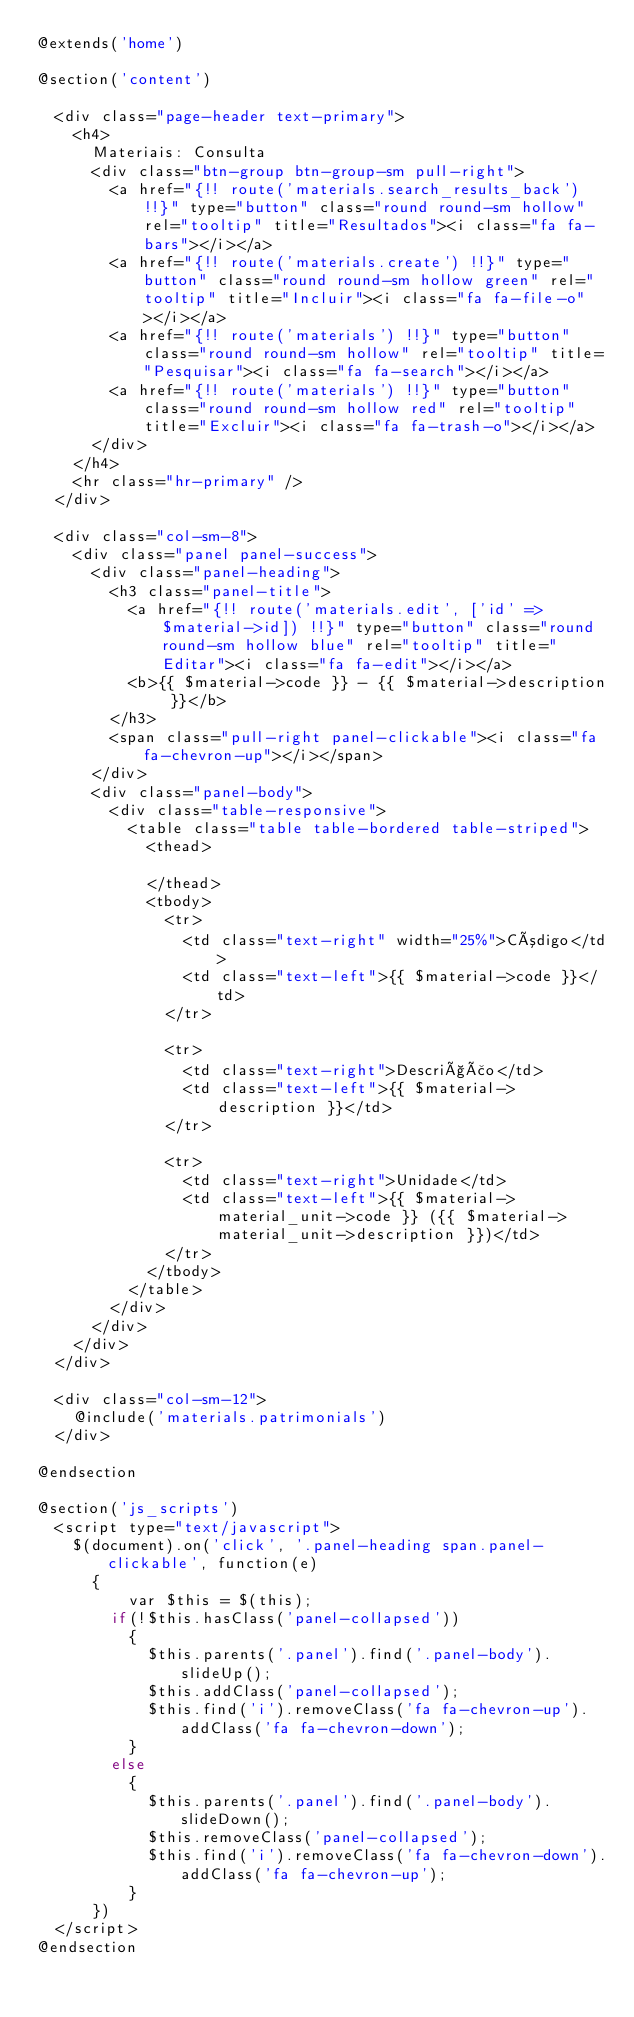<code> <loc_0><loc_0><loc_500><loc_500><_PHP_>@extends('home')

@section('content')

	<div class="page-header text-primary">
   	<h4>
     	Materiais: Consulta
     	<div class="btn-group btn-group-sm pull-right">
     		<a href="{!! route('materials.search_results_back') !!}" type="button" class="round round-sm hollow" rel="tooltip" title="Resultados"><i class="fa fa-bars"></i></a>
        <a href="{!! route('materials.create') !!}" type="button" class="round round-sm hollow green" rel="tooltip" title="Incluir"><i class="fa fa-file-o"></i></a>
     		<a href="{!! route('materials') !!}" type="button" class="round round-sm hollow" rel="tooltip" title="Pesquisar"><i class="fa fa-search"></i></a>
        <a href="{!! route('materials') !!}" type="button" class="round round-sm hollow red" rel="tooltip" title="Excluir"><i class="fa fa-trash-o"></i></a>
    	</div>
   	</h4>
   	<hr class="hr-primary" />
  </div>

  <div class="col-sm-8">
    <div class="panel panel-success">
      <div class="panel-heading">
        <h3 class="panel-title">
          <a href="{!! route('materials.edit', ['id' => $material->id]) !!}" type="button" class="round round-sm hollow blue" rel="tooltip" title="Editar"><i class="fa fa-edit"></i></a>
          <b>{{ $material->code }} - {{ $material->description }}</b>
        </h3>
        <span class="pull-right panel-clickable"><i class="fa fa-chevron-up"></i></span>
      </div>
      <div class="panel-body">
        <div class="table-responsive">
          <table class="table table-bordered table-striped">
            <thead>
              
            </thead>
            <tbody>
              <tr>
                <td class="text-right" width="25%">Código</td>
                <td class="text-left">{{ $material->code }}</td>
              </tr>

              <tr>
                <td class="text-right">Descrição</td>
                <td class="text-left">{{ $material->description }}</td>
              </tr>

              <tr>
                <td class="text-right">Unidade</td>
                <td class="text-left">{{ $material->material_unit->code }} ({{ $material->material_unit->description }})</td>
              </tr>
            </tbody>
          </table>
        </div>
      </div>
    </div>
  </div>

  <div class="col-sm-12">
    @include('materials.patrimonials')
  </div>
    
@endsection

@section('js_scripts')
  <script type="text/javascript">
    $(document).on('click', '.panel-heading span.panel-clickable', function(e)
      {
          var $this = $(this);
        if(!$this.hasClass('panel-collapsed')) 
          {
            $this.parents('.panel').find('.panel-body').slideUp();
            $this.addClass('panel-collapsed');
            $this.find('i').removeClass('fa fa-chevron-up').addClass('fa fa-chevron-down');
          } 
        else 
          {
            $this.parents('.panel').find('.panel-body').slideDown();
            $this.removeClass('panel-collapsed');
            $this.find('i').removeClass('fa fa-chevron-down').addClass('fa fa-chevron-up');
          }
      })
  </script>
@endsection
  </code> 